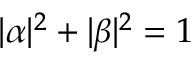Convert formula to latex. <formula><loc_0><loc_0><loc_500><loc_500>| \alpha | ^ { 2 } + | \beta | ^ { 2 } = 1</formula> 